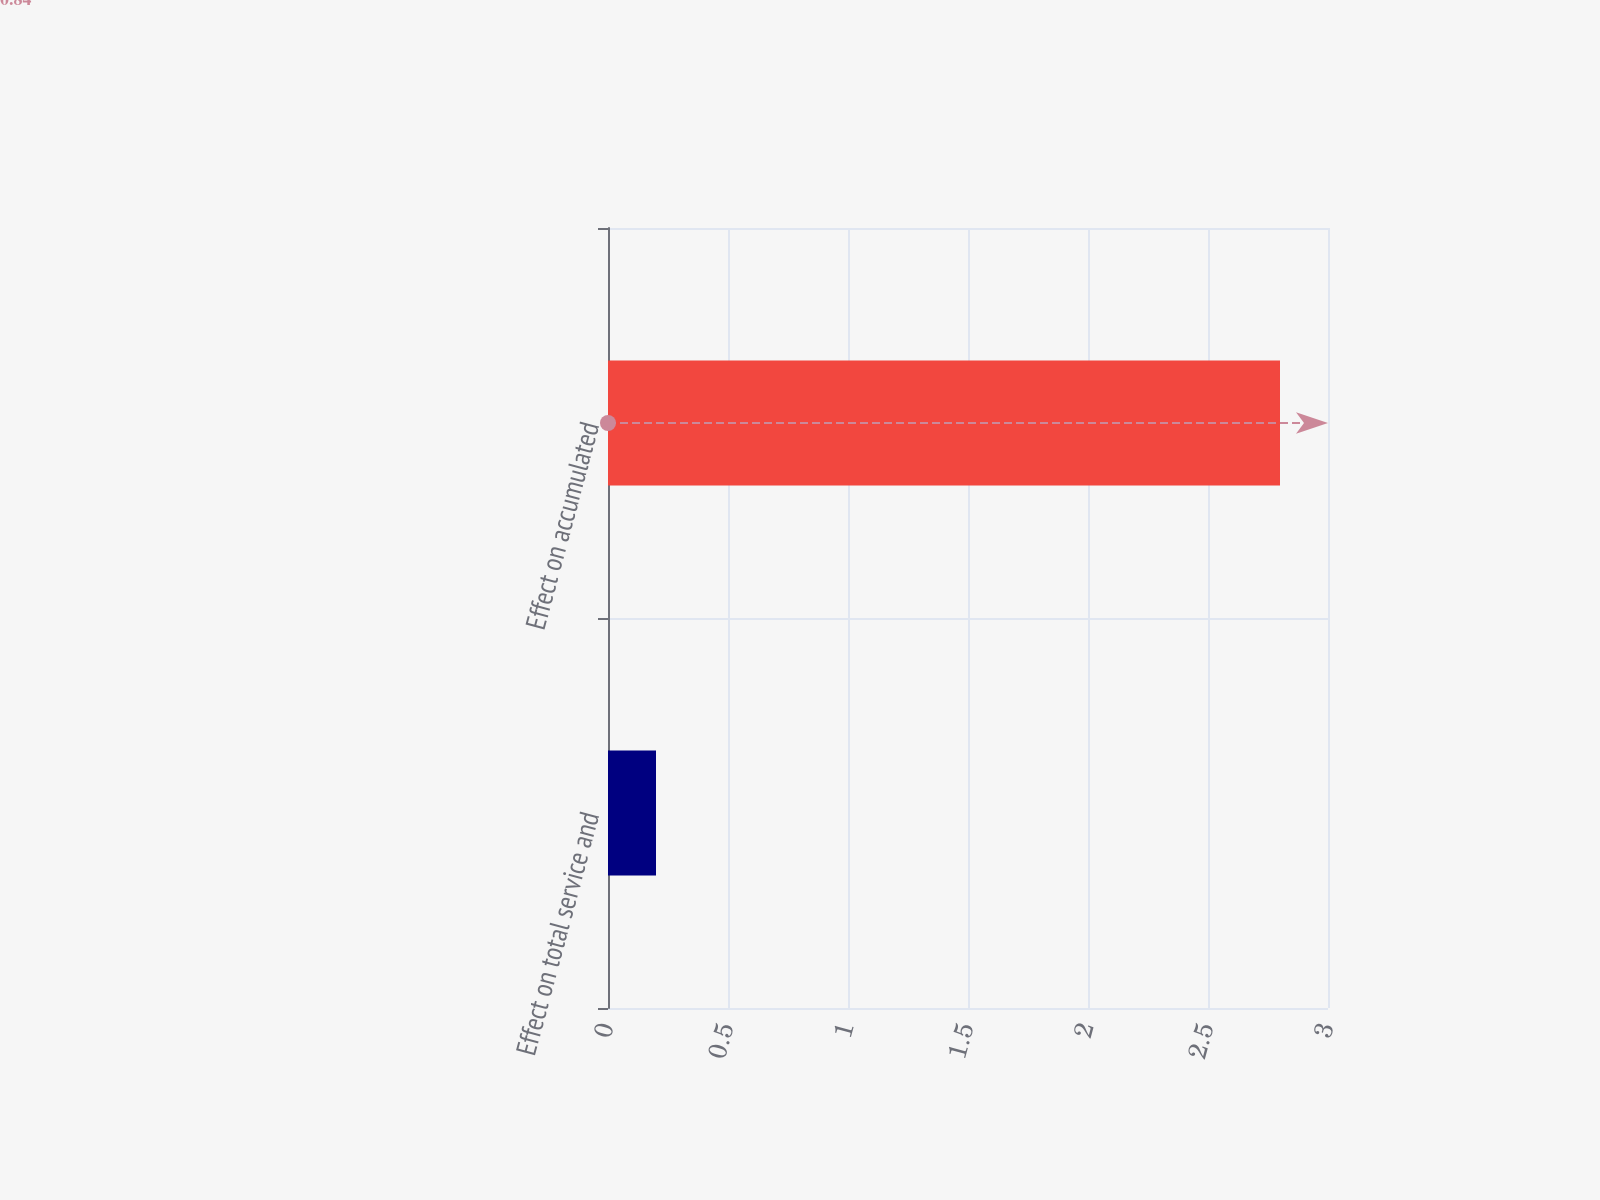Convert chart. <chart><loc_0><loc_0><loc_500><loc_500><bar_chart><fcel>Effect on total service and<fcel>Effect on accumulated<nl><fcel>0.2<fcel>2.8<nl></chart> 